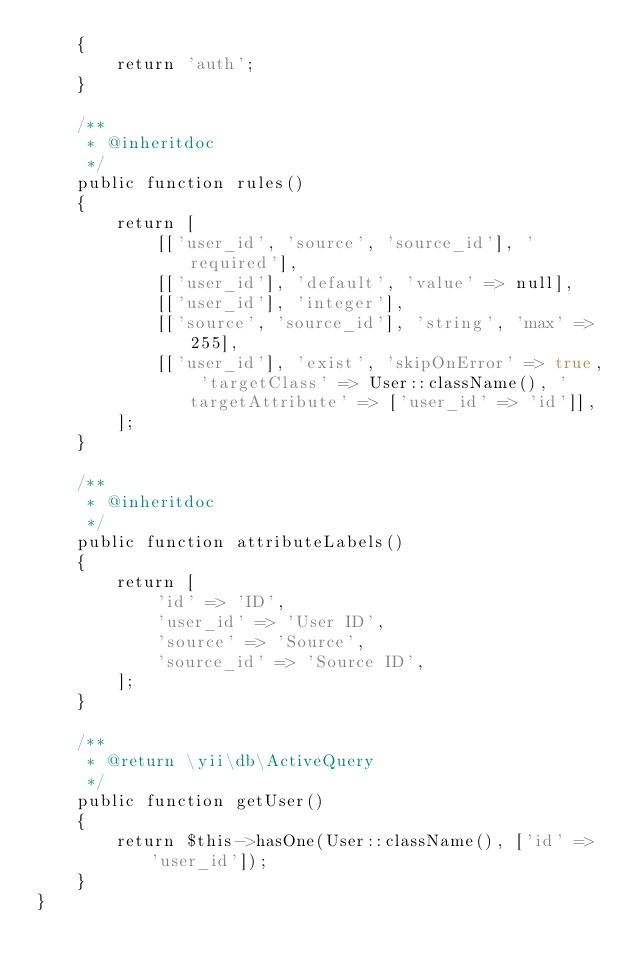Convert code to text. <code><loc_0><loc_0><loc_500><loc_500><_PHP_>    {
        return 'auth';
    }

    /**
     * @inheritdoc
     */
    public function rules()
    {
        return [
            [['user_id', 'source', 'source_id'], 'required'],
            [['user_id'], 'default', 'value' => null],
            [['user_id'], 'integer'],
            [['source', 'source_id'], 'string', 'max' => 255],
            [['user_id'], 'exist', 'skipOnError' => true, 'targetClass' => User::className(), 'targetAttribute' => ['user_id' => 'id']],
        ];
    }

    /**
     * @inheritdoc
     */
    public function attributeLabels()
    {
        return [
            'id' => 'ID',
            'user_id' => 'User ID',
            'source' => 'Source',
            'source_id' => 'Source ID',
        ];
    }

    /**
     * @return \yii\db\ActiveQuery
     */
    public function getUser()
    {
        return $this->hasOne(User::className(), ['id' => 'user_id']);
    }
}
</code> 